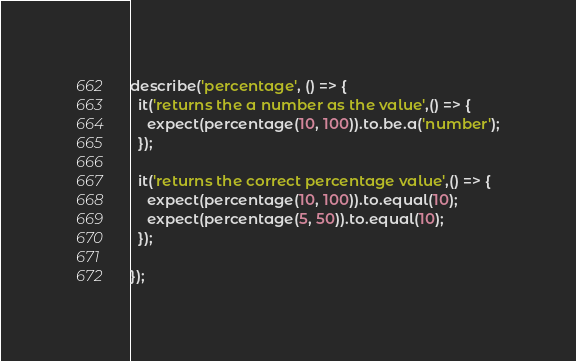<code> <loc_0><loc_0><loc_500><loc_500><_JavaScript_>describe('percentage', () => {
  it('returns the a number as the value',() => {
    expect(percentage(10, 100)).to.be.a('number');
  });

  it('returns the correct percentage value',() => {
    expect(percentage(10, 100)).to.equal(10);
    expect(percentage(5, 50)).to.equal(10);
  });

});

</code> 